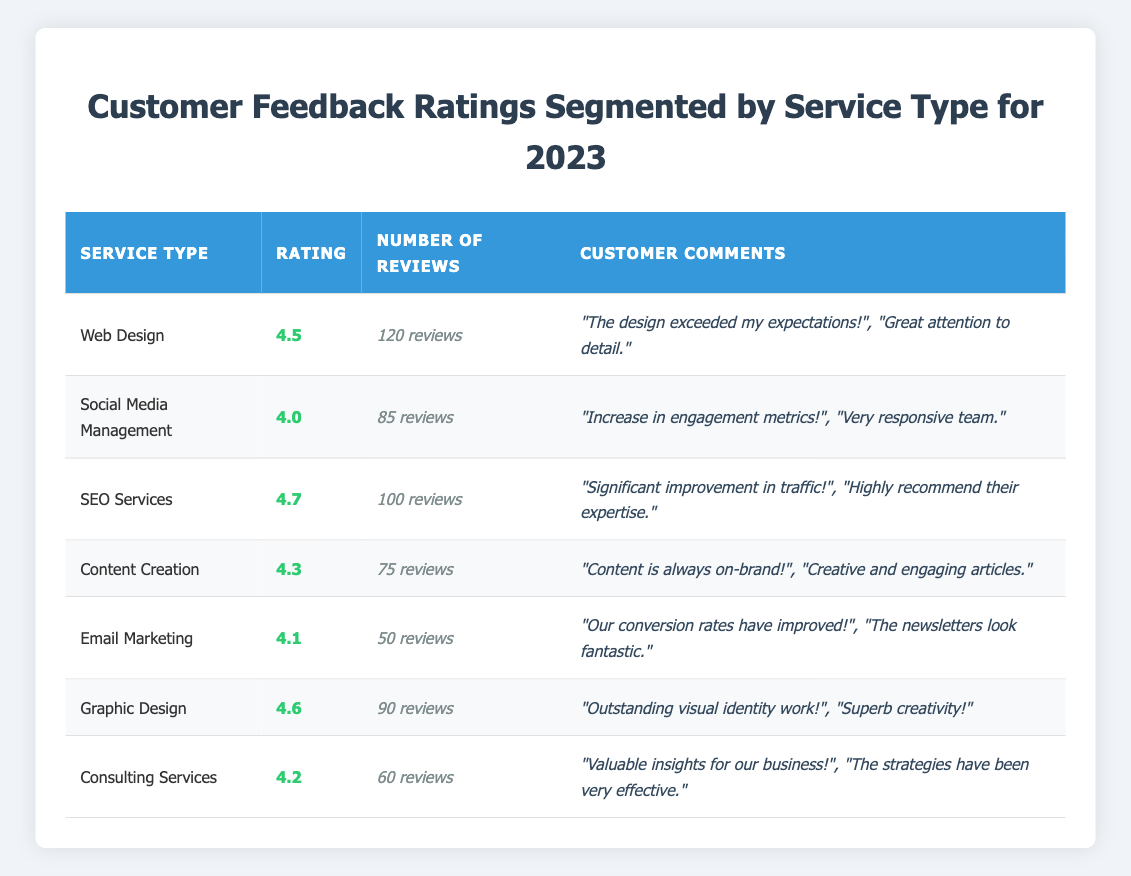What is the rating for SEO Services? The table shows the rating for SEO Services, which is listed in the second column. It is clearly shown as 4.7.
Answer: 4.7 How many reviews did the Email Marketing service receive? Looking at the table, under the Email Marketing service, the number of reviews is found in the third column, which states 50 reviews.
Answer: 50 Which service type has the highest customer feedback rating? By comparing the ratings in the second column, SEO Services has the highest rating at 4.7, making it the top-rated service in the table.
Answer: SEO Services Is the rating for Graphic Design above 4.5? The rating for Graphic Design is shown as 4.6 in the table, which is indeed above 4.5. Thus, the statement is true.
Answer: Yes What is the average rating of the services listed? To calculate the average, sum all the ratings (4.5 + 4.0 + 4.7 + 4.3 + 4.1 + 4.6 + 4.2) to get 26.4, and then divide by the number of services (7). So, the average rating is 26.4 / 7 ≈ 3.77.
Answer: 3.77 Which service had the least number of reviews and what was its rating? The least number of reviews is 50 for Email Marketing, which has a rating of 4.1, as observed from the corresponding row in the table.
Answer: Email Marketing, 4.1 If we combine the reviews of Social Media Management and Content Creation, how many total reviews do we get? The total reviews for Social Media Management is 85 and Content Creation is 75. Adding these gives 85 + 75 = 160 total reviews.
Answer: 160 What percentage of reviews are from the Web Design service compared to the total number of reviews from all services? The total reviews from all services is 120 + 85 + 100 + 75 + 50 + 90 + 60 = 720. The percentage from Web Design is (120 / 720) * 100, which is approximately 16.67%.
Answer: 16.67% If you want a service with a rating of at least 4.5 and more than 80 reviews, which services would you choose? Looking at the table, both Web Design (4.5, 120 reviews) and SEO Services (4.7, 100 reviews) meet these criteria, while Social Media Management does not meet the rating, and Content Creation does not meet the review requirement.
Answer: Web Design, SEO Services Which services received customer comments, and how many comments are listed for each? The table shows that all services have customer comments listed. The number of comments varies, for Web Design there are 2 comments, Social Media Management has 2, SEO Services has 2, and so forth for each service listed.
Answer: All services received comments, 2 comments each 